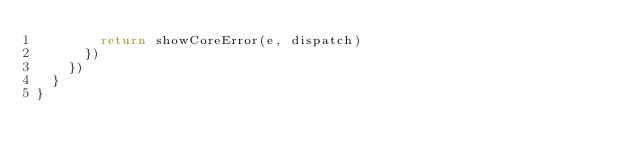<code> <loc_0><loc_0><loc_500><loc_500><_JavaScript_>        return showCoreError(e, dispatch)
      })
    })
  }
}
</code> 